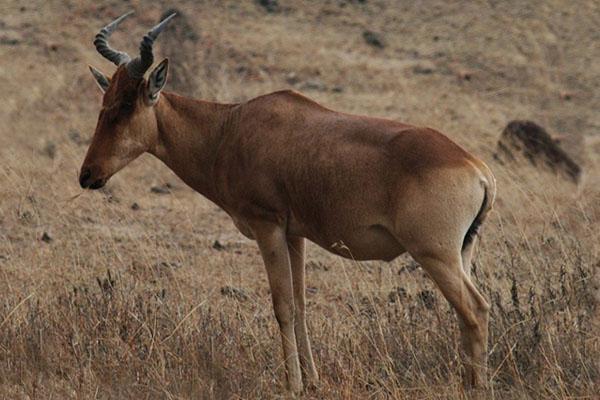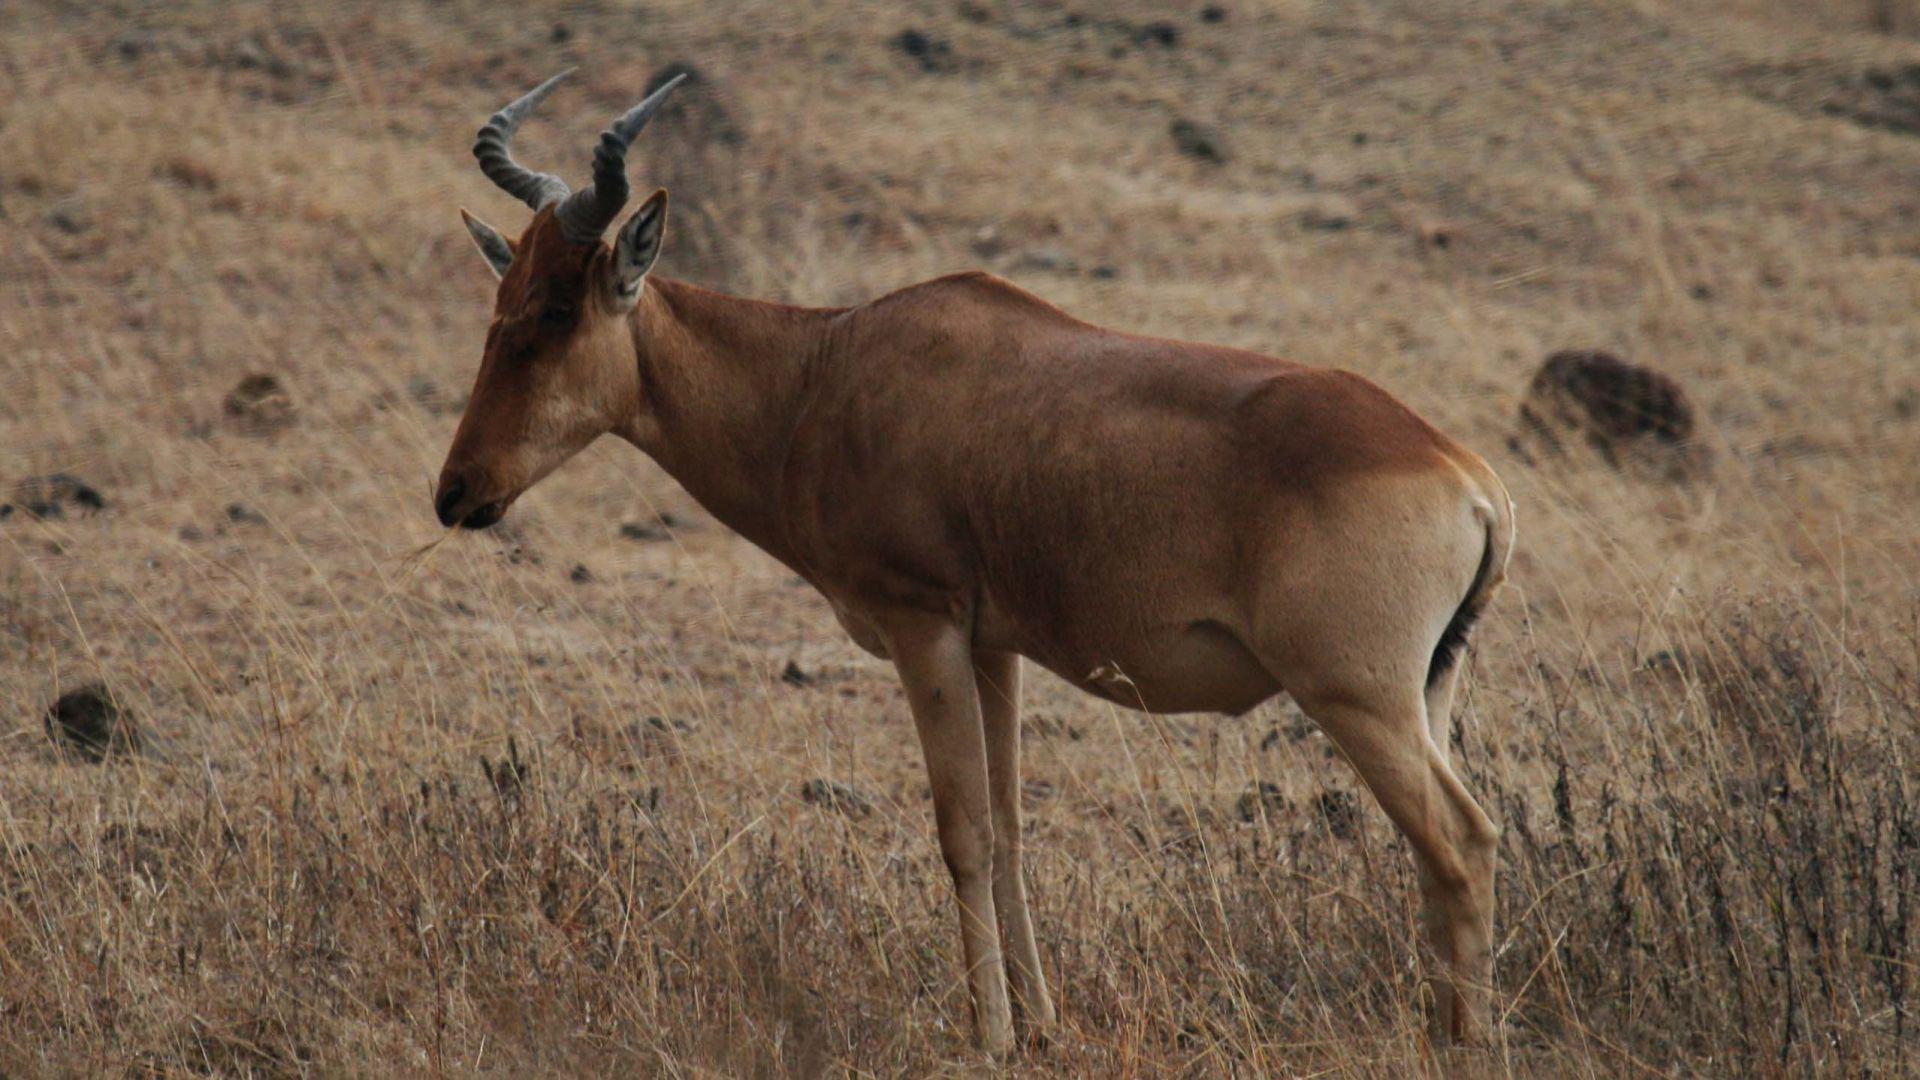The first image is the image on the left, the second image is the image on the right. For the images shown, is this caption "There are two animals in total." true? Answer yes or no. Yes. 